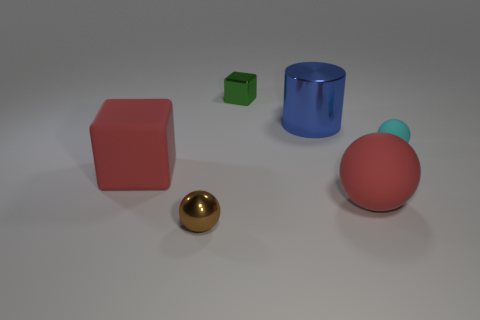What is the size of the rubber ball that is the same color as the large rubber cube?
Your answer should be very brief. Large. How many large matte things are the same color as the big cube?
Offer a terse response. 1. Do the big matte sphere and the big rubber cube have the same color?
Your answer should be compact. Yes. There is a big rubber object that is the same color as the big sphere; what is its shape?
Offer a very short reply. Cube. Is the color of the matte sphere that is left of the small cyan rubber object the same as the large matte object on the left side of the small brown shiny sphere?
Provide a succinct answer. Yes. How many small objects are on the right side of the large red ball and behind the cyan matte thing?
Keep it short and to the point. 0. What is the material of the green cube?
Ensure brevity in your answer.  Metal. What is the shape of the brown metal thing that is the same size as the cyan ball?
Ensure brevity in your answer.  Sphere. Do the cube in front of the tiny cyan object and the small ball that is on the right side of the big metallic thing have the same material?
Your answer should be compact. Yes. How many large purple shiny things are there?
Make the answer very short. 0. 